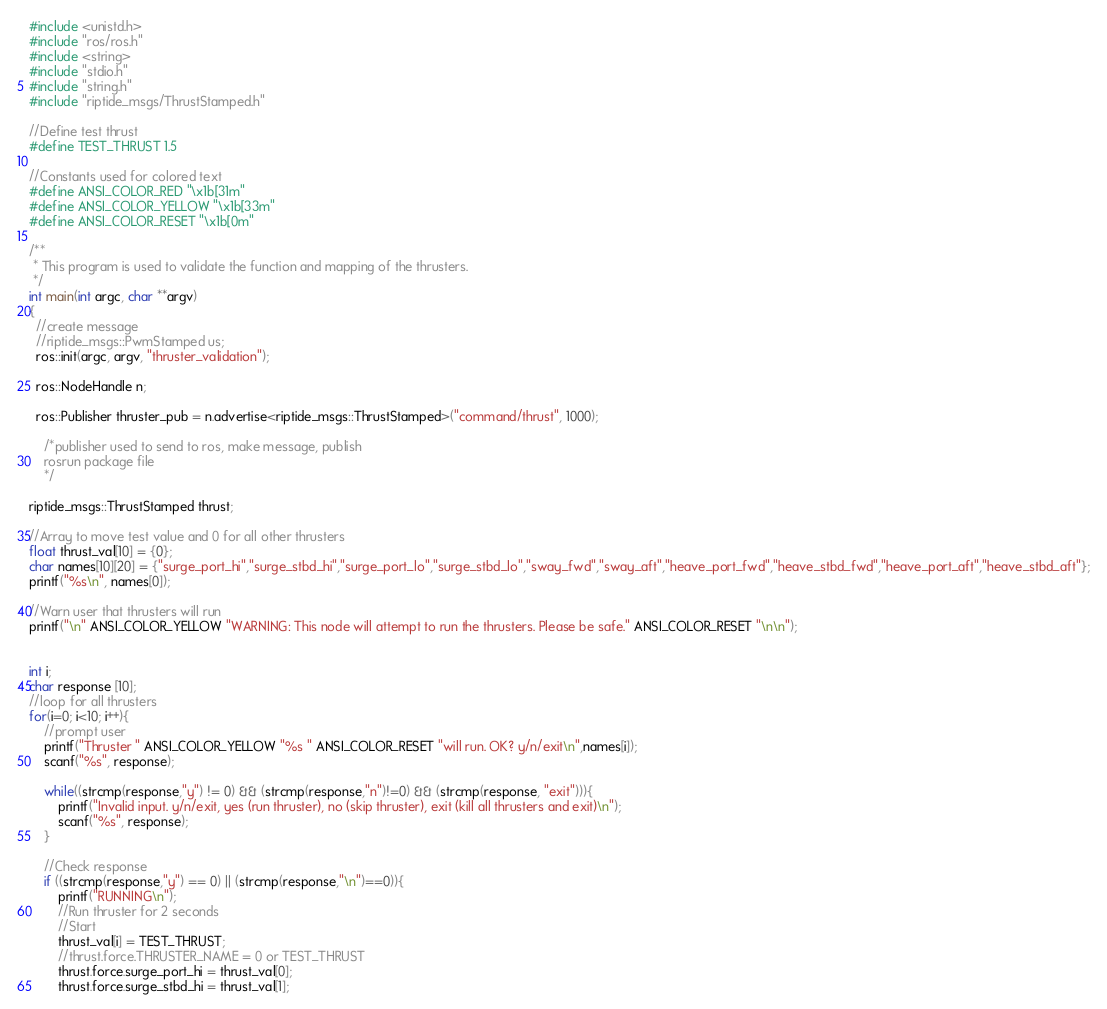Convert code to text. <code><loc_0><loc_0><loc_500><loc_500><_C++_>#include <unistd.h>
#include "ros/ros.h"
#include <string>
#include "stdio.h"
#include "string.h"
#include "riptide_msgs/ThrustStamped.h"

//Define test thrust
#define TEST_THRUST 1.5

//Constants used for colored text
#define ANSI_COLOR_RED "\x1b[31m"
#define ANSI_COLOR_YELLOW "\x1b[33m"
#define ANSI_COLOR_RESET "\x1b[0m"

/**
 * This program is used to validate the function and mapping of the thrusters.
 */
int main(int argc, char **argv)
{
  //create message
  //riptide_msgs::PwmStamped us;
  ros::init(argc, argv, "thruster_validation");

  ros::NodeHandle n;

  ros::Publisher thruster_pub = n.advertise<riptide_msgs::ThrustStamped>("command/thrust", 1000);

    /*publisher used to send to ros, make message, publish
    rosrun package file
    */

riptide_msgs::ThrustStamped thrust;

//Array to move test value and 0 for all other thrusters
float thrust_val[10] = {0};
char names[10][20] = {"surge_port_hi","surge_stbd_hi","surge_port_lo","surge_stbd_lo","sway_fwd","sway_aft","heave_port_fwd","heave_stbd_fwd","heave_port_aft","heave_stbd_aft"};
printf("%s\n", names[0]);

//Warn user that thrusters will run
printf("\n" ANSI_COLOR_YELLOW "WARNING: This node will attempt to run the thrusters. Please be safe." ANSI_COLOR_RESET "\n\n");


int i;
char response [10];
//loop for all thrusters
for(i=0; i<10; i++){
    //prompt user
    printf("Thruster " ANSI_COLOR_YELLOW "%s " ANSI_COLOR_RESET "will run. OK? y/n/exit\n",names[i]);
    scanf("%s", response);
    
    while((strcmp(response,"y") != 0) && (strcmp(response,"n")!=0) && (strcmp(response, "exit"))){
        printf("Invalid input. y/n/exit, yes (run thruster), no (skip thruster), exit (kill all thrusters and exit)\n");
        scanf("%s", response);
    }     

    //Check response
    if ((strcmp(response,"y") == 0) || (strcmp(response,"\n")==0)){
        printf("RUNNING\n");
        //Run thruster for 2 seconds
        //Start
        thrust_val[i] = TEST_THRUST;
        //thrust.force.THRUSTER_NAME = 0 or TEST_THRUST
        thrust.force.surge_port_hi = thrust_val[0];
        thrust.force.surge_stbd_hi = thrust_val[1];</code> 